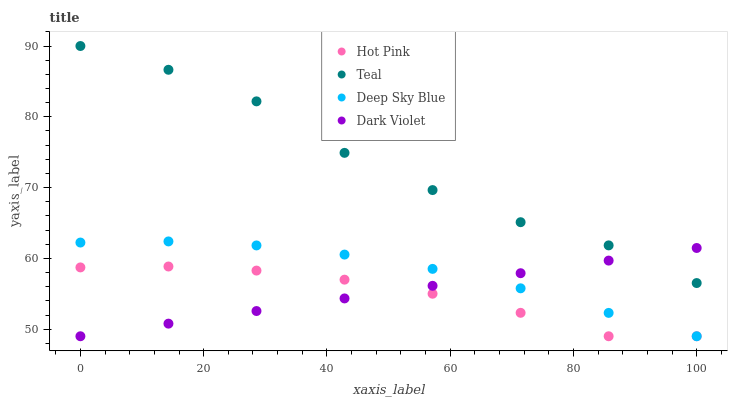Does Hot Pink have the minimum area under the curve?
Answer yes or no. Yes. Does Teal have the maximum area under the curve?
Answer yes or no. Yes. Does Deep Sky Blue have the minimum area under the curve?
Answer yes or no. No. Does Deep Sky Blue have the maximum area under the curve?
Answer yes or no. No. Is Dark Violet the smoothest?
Answer yes or no. Yes. Is Teal the roughest?
Answer yes or no. Yes. Is Hot Pink the smoothest?
Answer yes or no. No. Is Hot Pink the roughest?
Answer yes or no. No. Does Dark Violet have the lowest value?
Answer yes or no. Yes. Does Teal have the lowest value?
Answer yes or no. No. Does Teal have the highest value?
Answer yes or no. Yes. Does Deep Sky Blue have the highest value?
Answer yes or no. No. Is Hot Pink less than Teal?
Answer yes or no. Yes. Is Teal greater than Deep Sky Blue?
Answer yes or no. Yes. Does Hot Pink intersect Dark Violet?
Answer yes or no. Yes. Is Hot Pink less than Dark Violet?
Answer yes or no. No. Is Hot Pink greater than Dark Violet?
Answer yes or no. No. Does Hot Pink intersect Teal?
Answer yes or no. No. 